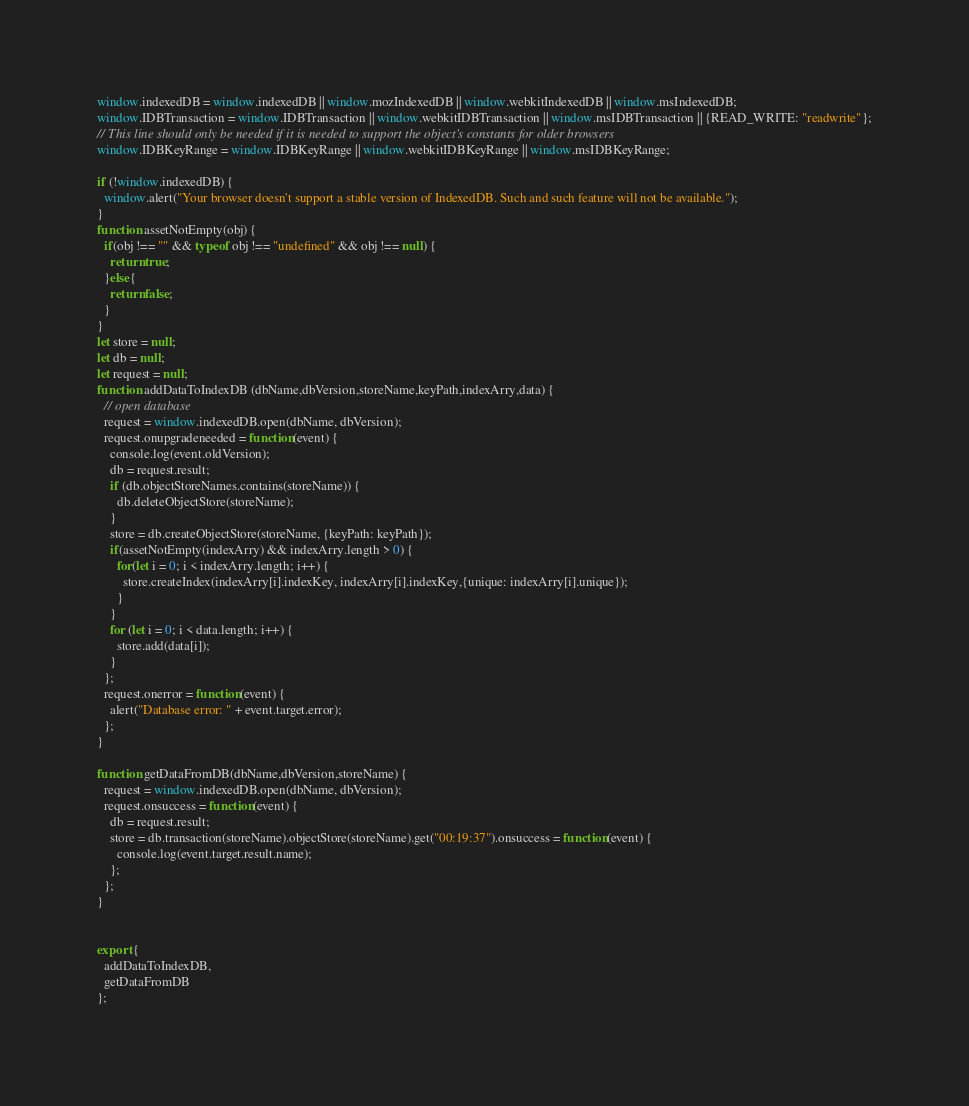<code> <loc_0><loc_0><loc_500><loc_500><_JavaScript_>window.indexedDB = window.indexedDB || window.mozIndexedDB || window.webkitIndexedDB || window.msIndexedDB;
window.IDBTransaction = window.IDBTransaction || window.webkitIDBTransaction || window.msIDBTransaction || {READ_WRITE: "readwrite"};
// This line should only be needed if it is needed to support the object's constants for older browsers
window.IDBKeyRange = window.IDBKeyRange || window.webkitIDBKeyRange || window.msIDBKeyRange;

if (!window.indexedDB) {
  window.alert("Your browser doesn't support a stable version of IndexedDB. Such and such feature will not be available.");
}
function assetNotEmpty(obj) {
  if(obj !== "" && typeof obj !== "undefined" && obj !== null) {
    return true;
  }else{
    return false;
  }
}
let store = null;
let db = null;
let request = null;
function addDataToIndexDB (dbName,dbVersion,storeName,keyPath,indexArry,data) {
  // open database
  request = window.indexedDB.open(dbName, dbVersion);
  request.onupgradeneeded = function(event) {
    console.log(event.oldVersion);
    db = request.result;
    if (db.objectStoreNames.contains(storeName)) {
      db.deleteObjectStore(storeName);
    }
    store = db.createObjectStore(storeName, {keyPath: keyPath});
    if(assetNotEmpty(indexArry) && indexArry.length > 0) {
      for(let i = 0; i < indexArry.length; i++) {
        store.createIndex(indexArry[i].indexKey, indexArry[i].indexKey,{unique: indexArry[i].unique});
      }
    }
    for (let i = 0; i < data.length; i++) {
      store.add(data[i]);
    }
  };
  request.onerror = function(event) {
    alert("Database error: " + event.target.error);
  };
}

function getDataFromDB(dbName,dbVersion,storeName) {
  request = window.indexedDB.open(dbName, dbVersion);
  request.onsuccess = function(event) {
    db = request.result;
    store = db.transaction(storeName).objectStore(storeName).get("00:19:37").onsuccess = function(event) {
      console.log(event.target.result.name);
    };
  };
}


export {
  addDataToIndexDB,
  getDataFromDB
};
</code> 